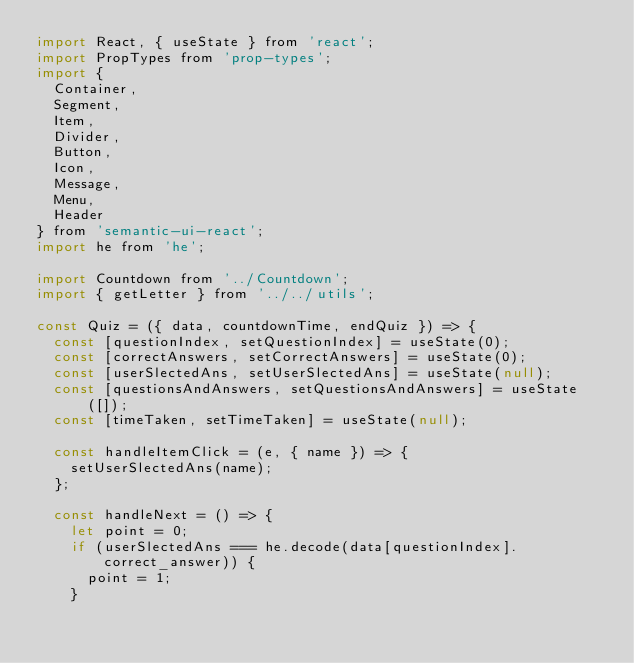Convert code to text. <code><loc_0><loc_0><loc_500><loc_500><_JavaScript_>import React, { useState } from 'react';
import PropTypes from 'prop-types';
import {
  Container,
  Segment,
  Item,
  Divider,
  Button,
  Icon,
  Message,
  Menu,
  Header
} from 'semantic-ui-react';
import he from 'he';

import Countdown from '../Countdown';
import { getLetter } from '../../utils';

const Quiz = ({ data, countdownTime, endQuiz }) => {
  const [questionIndex, setQuestionIndex] = useState(0);
  const [correctAnswers, setCorrectAnswers] = useState(0);
  const [userSlectedAns, setUserSlectedAns] = useState(null);
  const [questionsAndAnswers, setQuestionsAndAnswers] = useState([]);
  const [timeTaken, setTimeTaken] = useState(null);

  const handleItemClick = (e, { name }) => {
    setUserSlectedAns(name);
  };

  const handleNext = () => {
    let point = 0;
    if (userSlectedAns === he.decode(data[questionIndex].correct_answer)) {
      point = 1;
    }
</code> 